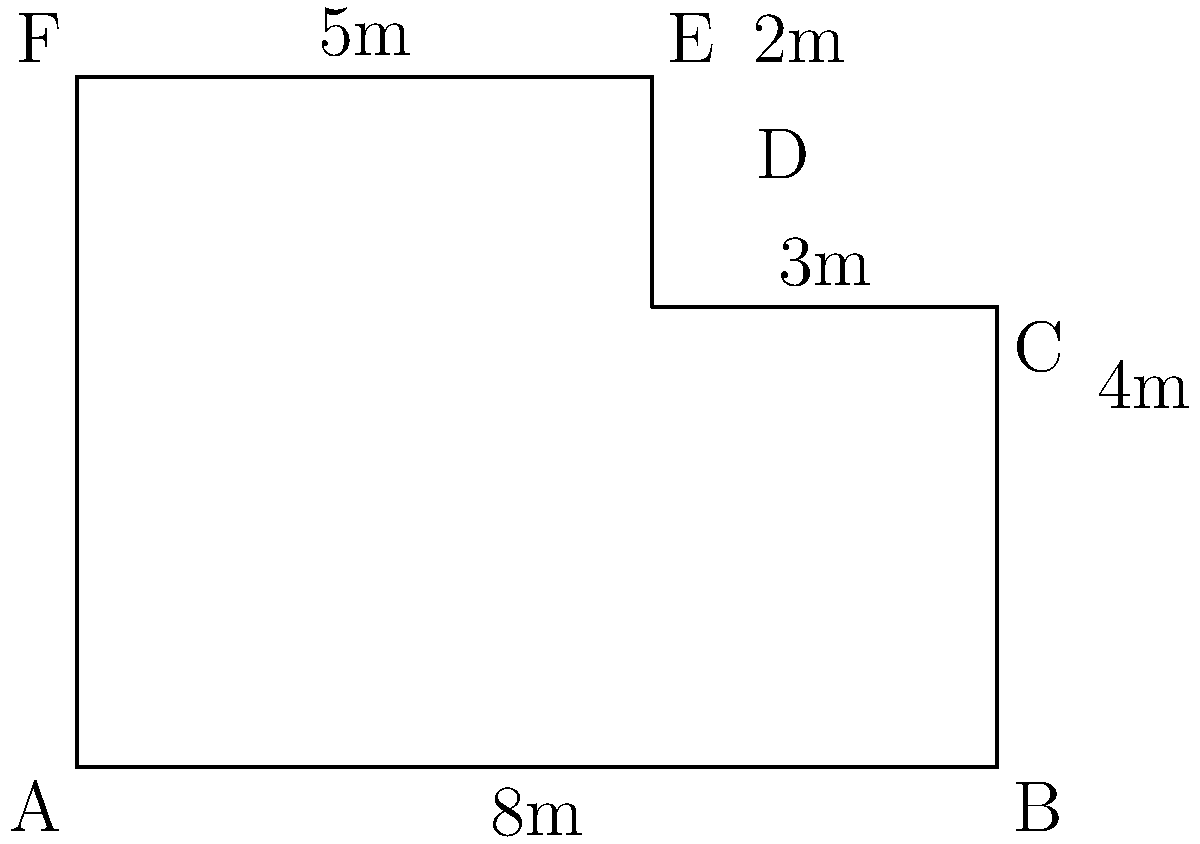In a high-profile legal case, the courtroom's layout has become a crucial element. The irregularly shaped courtroom is represented by the figure above. Calculate the total area of the courtroom in square meters. To find the area of this irregularly shaped courtroom, we can break it down into two rectangles:

1. Rectangle ABCF:
   Width = 8m
   Height = 4m
   Area of ABCF = $8 \times 4 = 32$ sq m

2. Rectangle DEF:
   Width = 5m
   Height = 2m
   Area of DEF = $5 \times 2 = 10$ sq m

Total area of the courtroom:
$$ \text{Total Area} = \text{Area of ABCF} + \text{Area of DEF} $$
$$ \text{Total Area} = 32 + 10 = 42 \text{ sq m} $$

Therefore, the total area of the courtroom is 42 square meters.
Answer: 42 sq m 